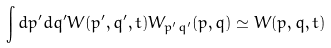Convert formula to latex. <formula><loc_0><loc_0><loc_500><loc_500>\int d p ^ { \prime } d q ^ { \prime } W ( p ^ { \prime } , q ^ { \prime } , t ) W _ { p ^ { \prime } q ^ { \prime } } ( p , q ) \simeq W ( p , q , t )</formula> 